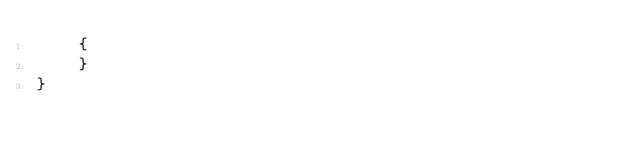<code> <loc_0><loc_0><loc_500><loc_500><_C#_>    {
    }
}
</code> 